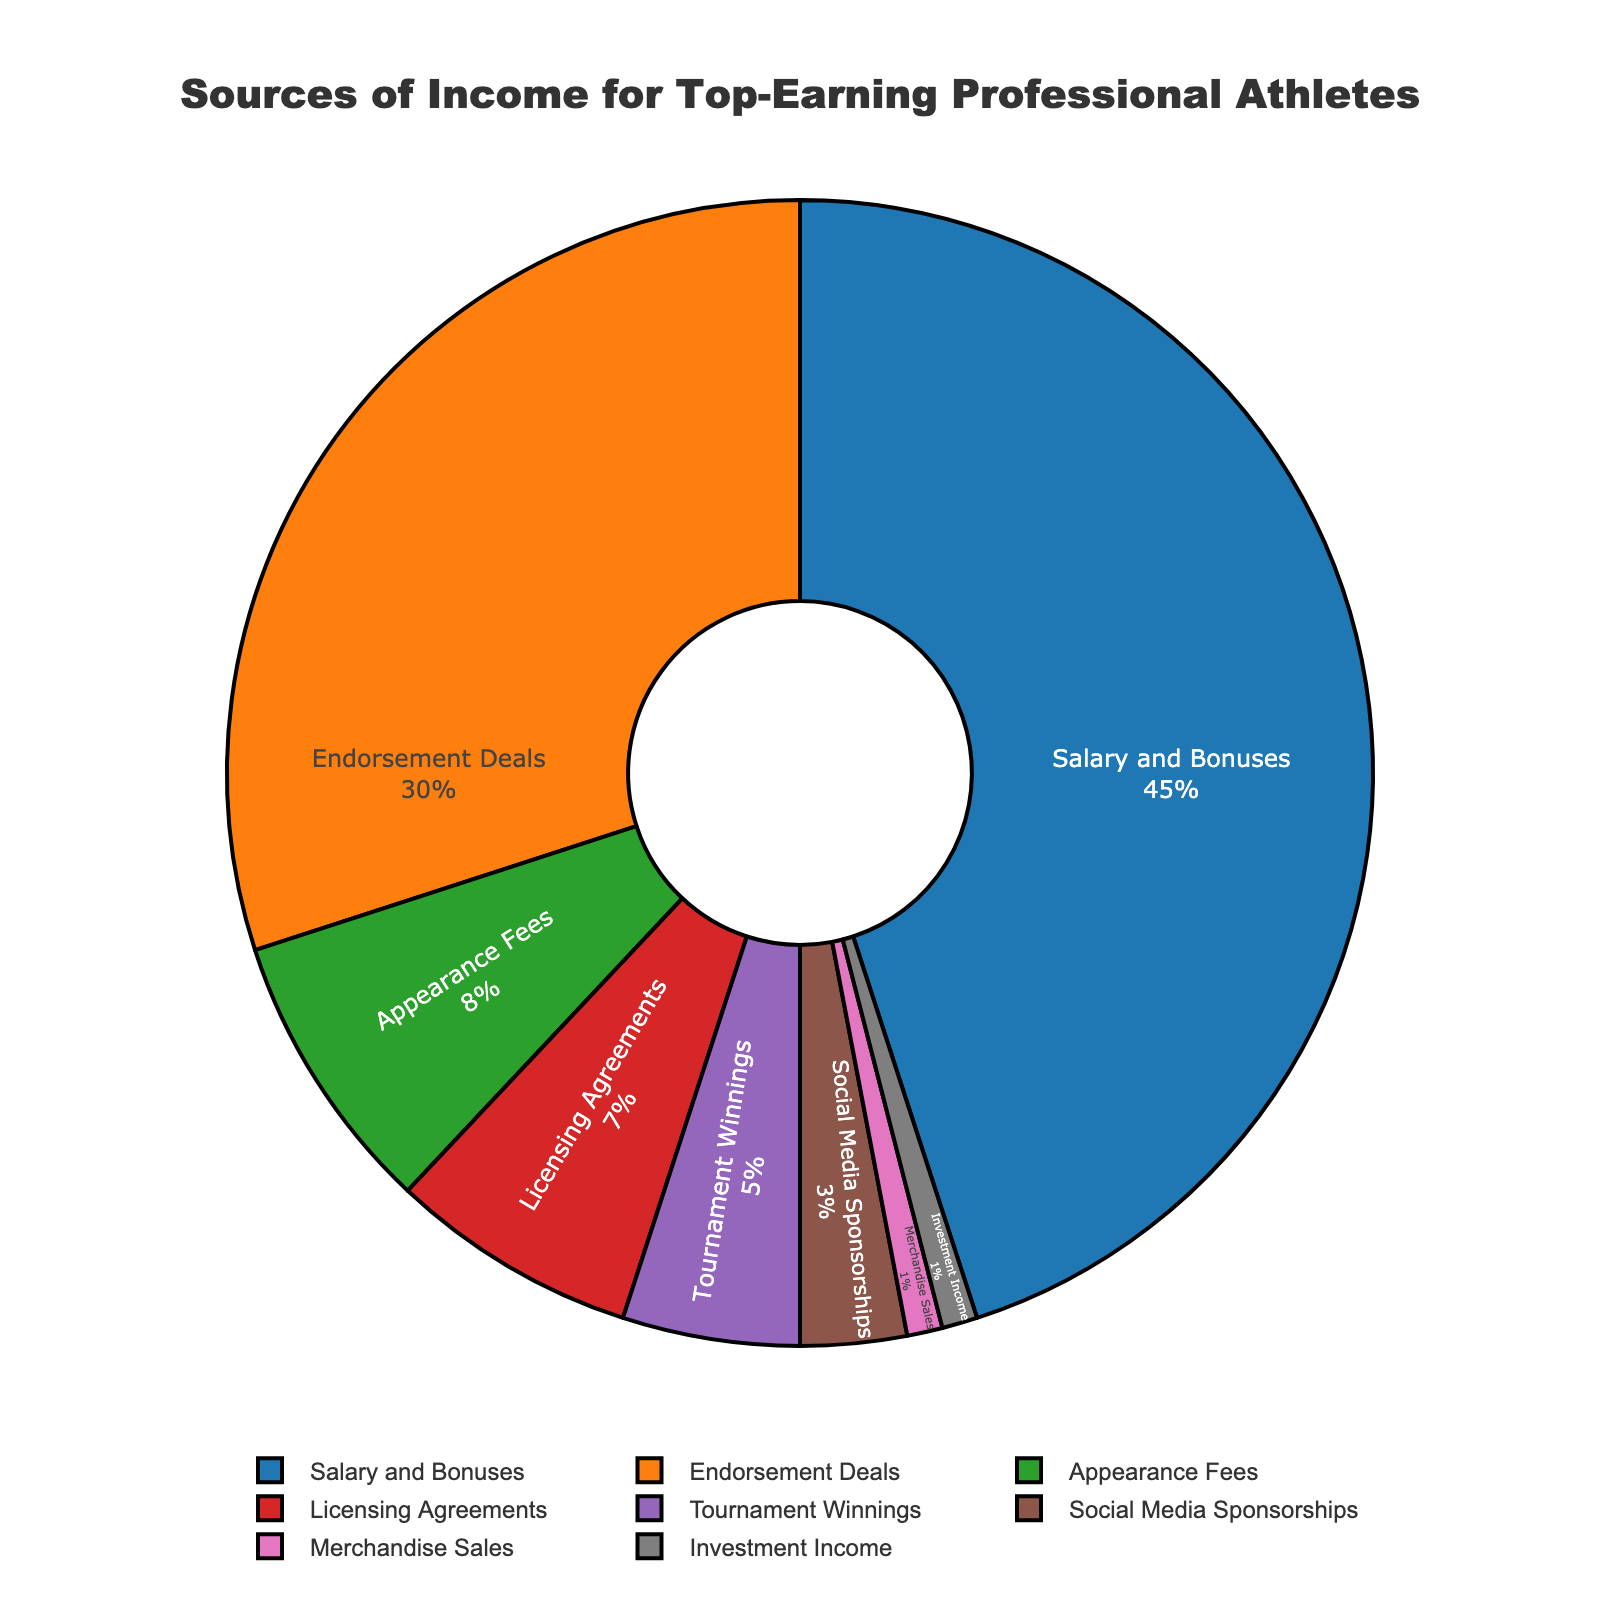What is the largest source of income for top-earning professional athletes? The pie chart shows that the largest segment is labeled "Salary and Bonuses" which occupies the greatest portion of the pie at 45%.
Answer: Salary and Bonuses Which source of income is the smallest for top-earning professional athletes? The smallest segment in the pie chart is labeled "Merchandise Sales" and "Investment Income," both of which have the smallest percentage at 1%.
Answer: Merchandise Sales and Investment Income How much larger is the percentage from Endorsement Deals compared to Appearance Fees? The pie chart shows that Endorsement Deals account for 30% and Appearance Fees account for 8%. To find the difference, subtract 8 from 30.
Answer: 22% What is the combined percentage of income from Social Media Sponsorships, Merchandise Sales, and Investment Income? From the pie chart, Social Media Sponsorships account for 3%, Merchandise Sales for 1%, and Investment Income for 1%. Summing these up, 3 + 1 + 1 = 5%.
Answer: 5% Which source of income represents more than one-quarter of the pie chart? The pie chart shows that "Salary and Bonuses" (45%) and "Endorsement Deals" (30%) constitute more than one-quarter of the total income sources, as each is greater than 25%.
Answer: Salary and Bonuses and Endorsement Deals How does the percentage of income from Licensing Agreements compare to Tournament Winnings? The pie chart shows Licensing Agreements at 7% and Tournament Winnings at 5%. Licensing Agreements have a greater percentage than Tournament Winnings by 2%.
Answer: 2% What's the combined percentage of income from sources less than 10% each? The sources under 10% are Appearance Fees (8%), Licensing Agreements (7%), Tournament Winnings (5%), Social Media Sponsorships (3%), Merchandise Sales (1%), and Investment Income (1%). Summing these percentages, 8 + 7 + 5 + 3 + 1 + 1 = 25%.
Answer: 25% Which sources of income use shades of red in the pie chart? The pie chart uses color to represent different segments. There's a segment colored in a red shade labeled as "Tournament Winnings" at 5%.
Answer: Tournament Winnings What percentage of income is not derived from direct earnings such as salary, bonuses, or tournament winnings? Direct earnings include Salary and Bonuses (45%) and Tournament Winnings (5%), summing to 50%. Subtracting from 100%, we get 100 - 50 = 50%.
Answer: 50% What is the percentage difference between the largest and smallest sources of income? The largest source is "Salary and Bonuses" at 45%, and the smallest sources are "Merchandise Sales" and "Investment Income" each at 1%. The difference is 45 - 1 = 44%.
Answer: 44% 